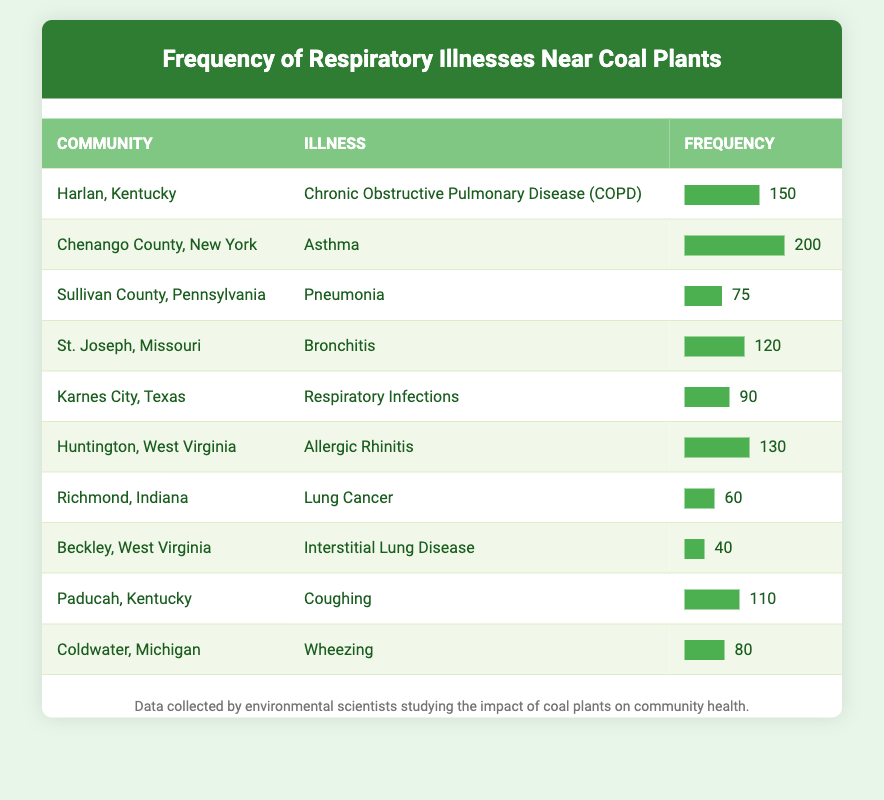What community reports the highest frequency of respiratory illnesses? The table indicates that Chenango County, New York, has the highest frequency reported at 200.
Answer: Chenango County, New York What is the frequency of Chronic Obstructive Pulmonary Disease (COPD) reported? According to the table, Harlan, Kentucky reports a frequency of 150 for Chronic Obstructive Pulmonary Disease (COPD).
Answer: 150 Which illness has the lowest frequency of reports? Looking at the data, Beckley, West Virginia reports the lowest frequency of 40 for Interstitial Lung Disease.
Answer: 40 What is the total frequency of respiratory infections and pneumonia combined? The frequency for Respiratory Infections from Karnes City, Texas is 90 and for Pneumonia from Sullivan County, Pennsylvania is 75. Adding these together gives 90 + 75 = 165.
Answer: 165 Is the frequency of Asthma greater than that of Bronchitis? From the table, Asthma frequency is 200 while Bronchitis frequency is 120. Since 200 is greater than 120, the statement is true.
Answer: Yes What is the average frequency of respiratory illnesses reported in the listed communities? To calculate the average, sum the frequencies: 150 + 200 + 75 + 120 + 90 + 130 + 60 + 40 + 110 + 80 = 1055. There are 10 communities, so the average is 1055 / 10 = 105.5.
Answer: 105.5 How many communities report a frequency of over 100? The table shows that Harlan (150), Chenango County (200), St. Joseph (120), Huntington (130), and Paducah (110) all report over 100. This gives a total of 5 communities.
Answer: 5 Is there a community reporting both Respiratory Infections and a frequency lower than 100? Looking at the table, Karnes City, Texas reports Respiratory Infections with a frequency of 90, which is indeed lower than 100. Therefore, the statement is true.
Answer: Yes Which illness has a higher frequency: Allergic Rhinitis or Lung Cancer? The frequency for Allergic Rhinitis from Huntington, West Virginia is 130, while Lung Cancer from Richmond, Indiana is 60. Since 130 is greater than 60, Allergic Rhinitis has a higher frequency.
Answer: Allergic Rhinitis 